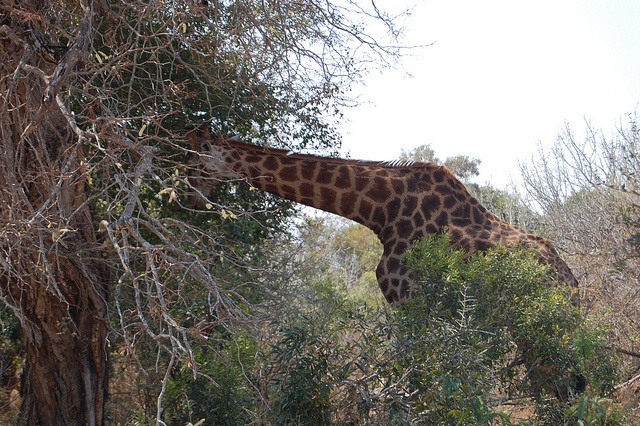Describe the objects in this image and their specific colors. I can see a giraffe in black, gray, and darkgreen tones in this image. 